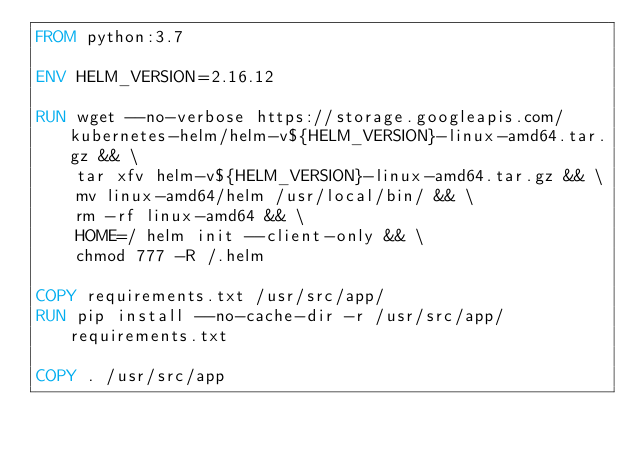Convert code to text. <code><loc_0><loc_0><loc_500><loc_500><_Dockerfile_>FROM python:3.7

ENV HELM_VERSION=2.16.12

RUN wget --no-verbose https://storage.googleapis.com/kubernetes-helm/helm-v${HELM_VERSION}-linux-amd64.tar.gz && \
    tar xfv helm-v${HELM_VERSION}-linux-amd64.tar.gz && \
    mv linux-amd64/helm /usr/local/bin/ && \
    rm -rf linux-amd64 && \
    HOME=/ helm init --client-only && \
    chmod 777 -R /.helm

COPY requirements.txt /usr/src/app/
RUN pip install --no-cache-dir -r /usr/src/app/requirements.txt

COPY . /usr/src/app
</code> 